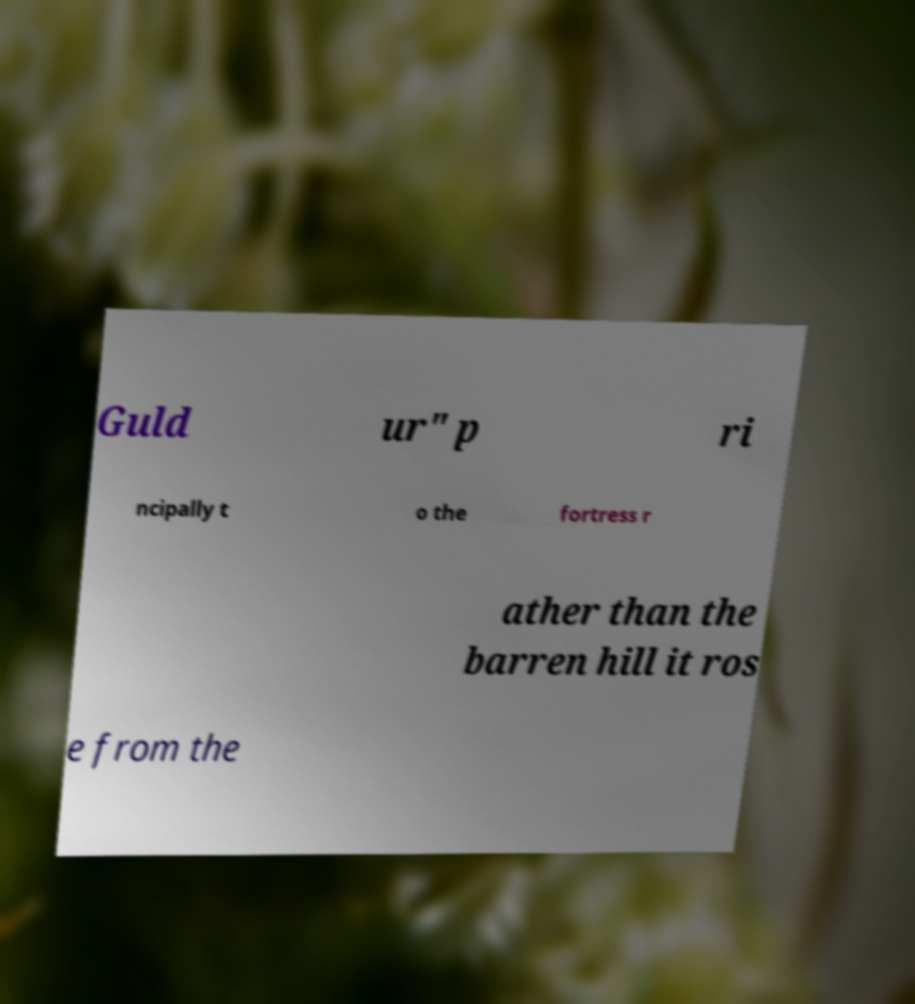Can you accurately transcribe the text from the provided image for me? Guld ur" p ri ncipally t o the fortress r ather than the barren hill it ros e from the 